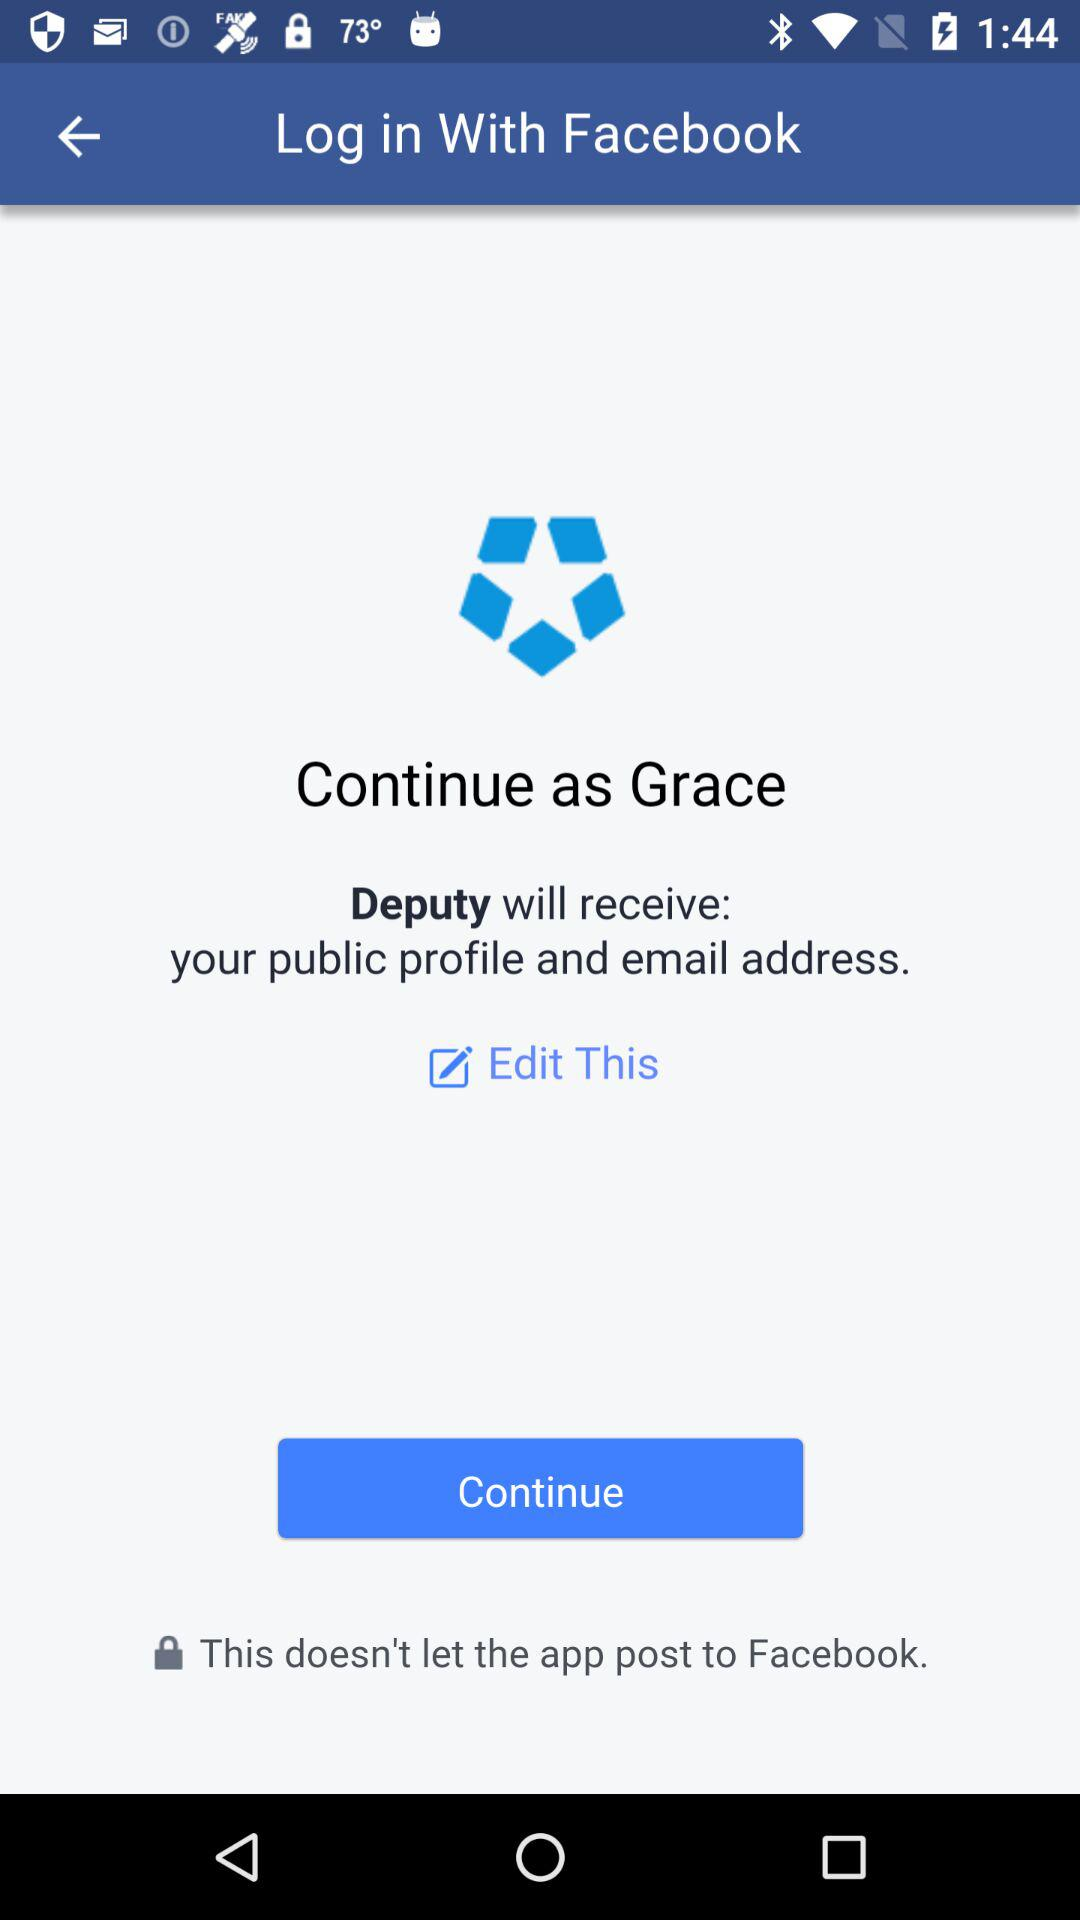What is the name of the user? The name of the user is Grace. 